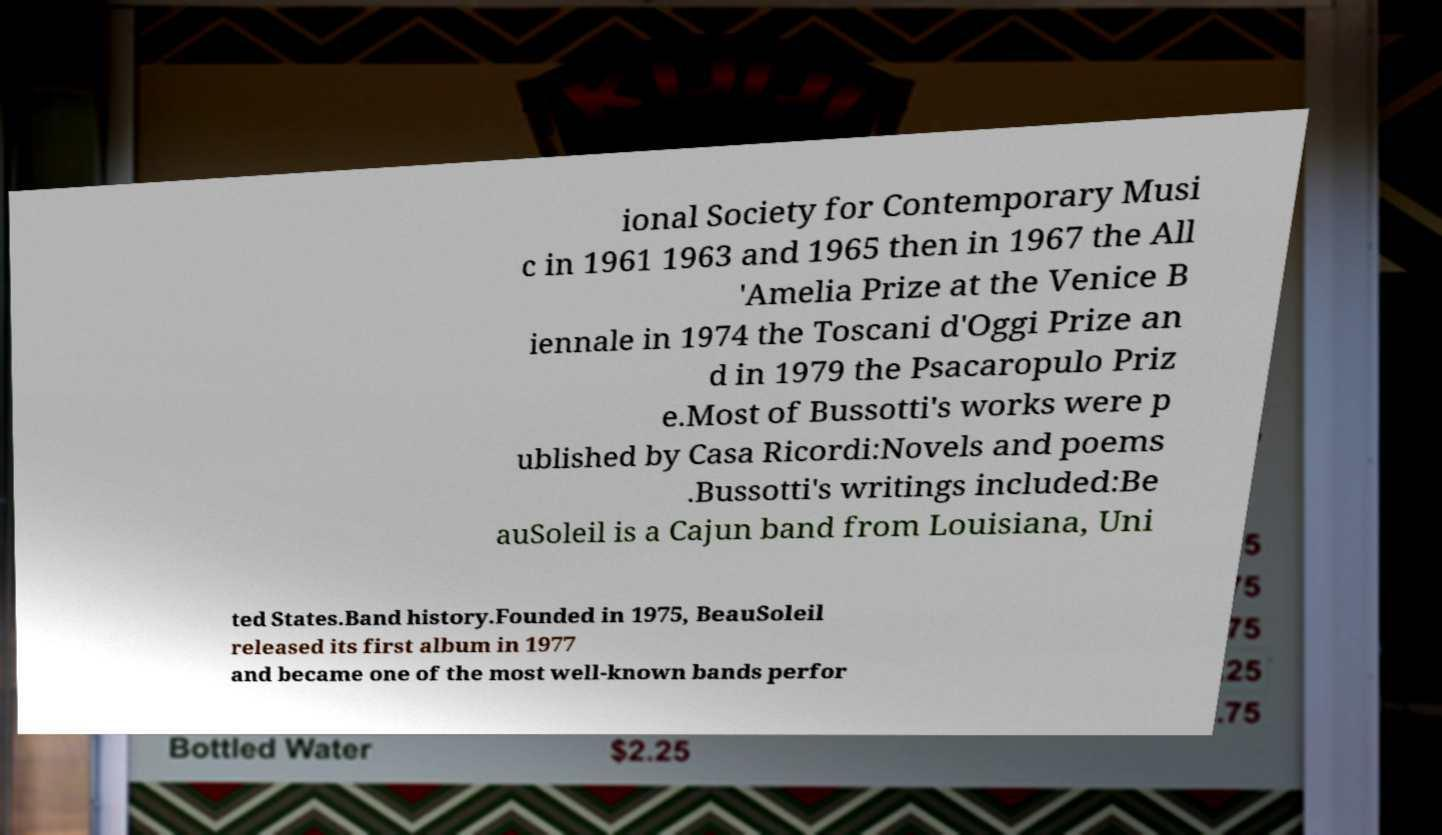Please read and relay the text visible in this image. What does it say? ional Society for Contemporary Musi c in 1961 1963 and 1965 then in 1967 the All 'Amelia Prize at the Venice B iennale in 1974 the Toscani d'Oggi Prize an d in 1979 the Psacaropulo Priz e.Most of Bussotti's works were p ublished by Casa Ricordi:Novels and poems .Bussotti's writings included:Be auSoleil is a Cajun band from Louisiana, Uni ted States.Band history.Founded in 1975, BeauSoleil released its first album in 1977 and became one of the most well-known bands perfor 